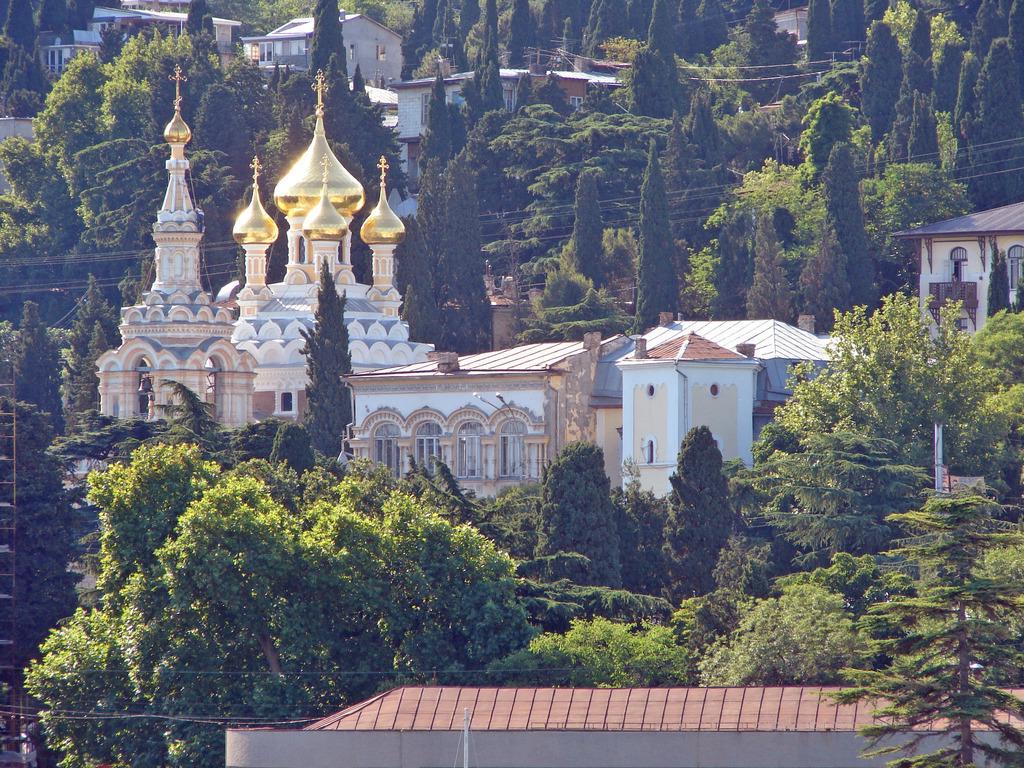How would you summarize this image in a sentence or two? In this image I can see number of trees and number of buildings. I can also see number of wires on the bottom side and in the centre of this image. 